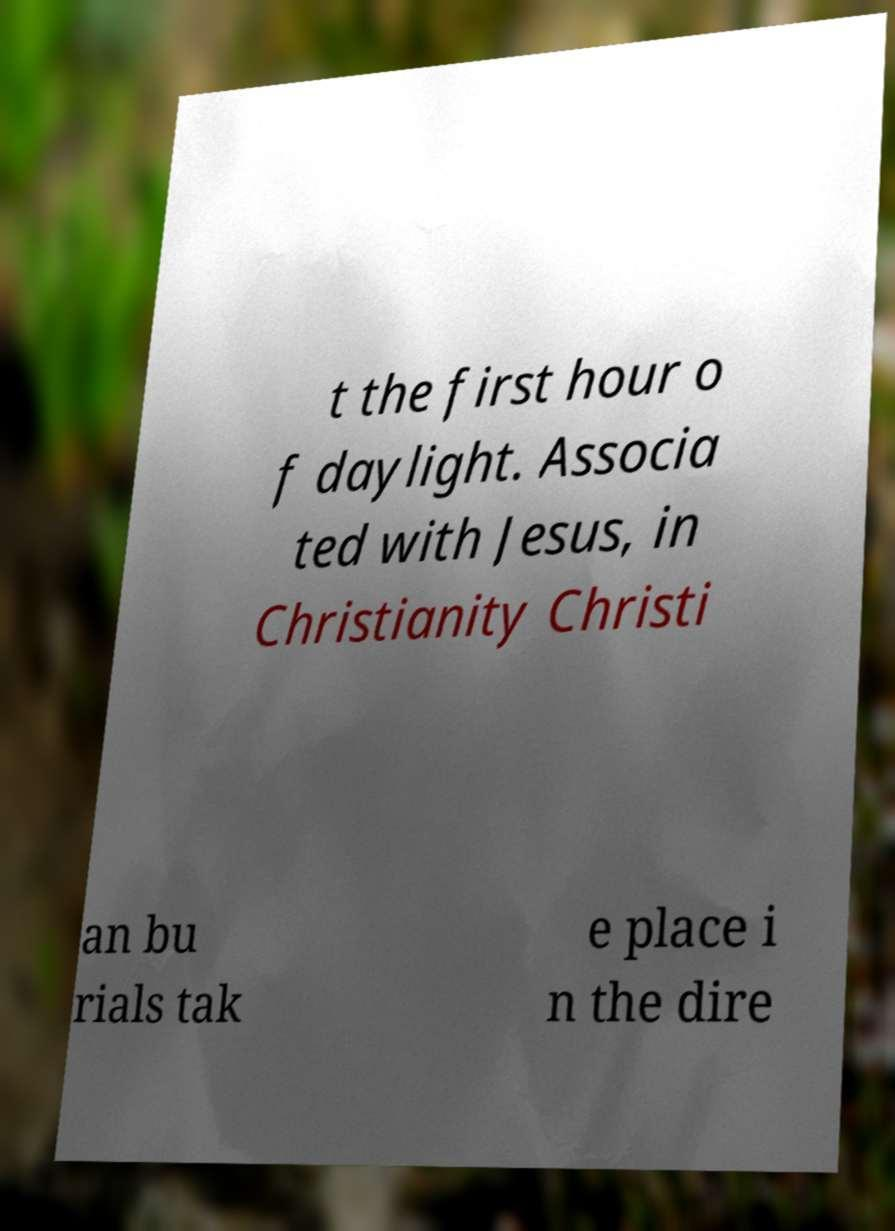Could you assist in decoding the text presented in this image and type it out clearly? t the first hour o f daylight. Associa ted with Jesus, in Christianity Christi an bu rials tak e place i n the dire 